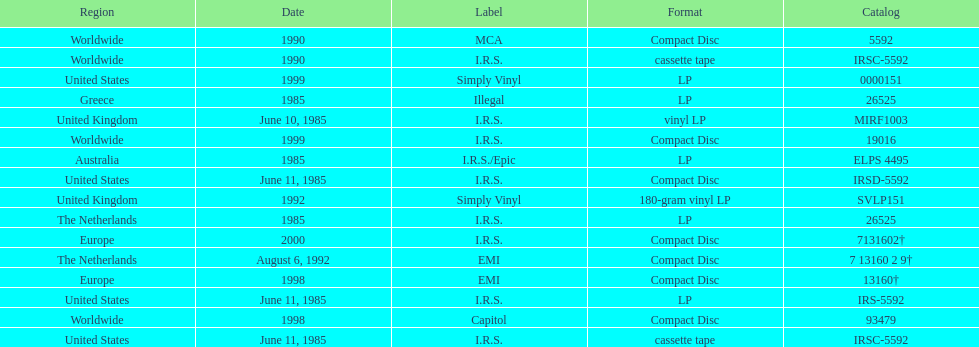In how many countries was the album released before 1990? 5. 